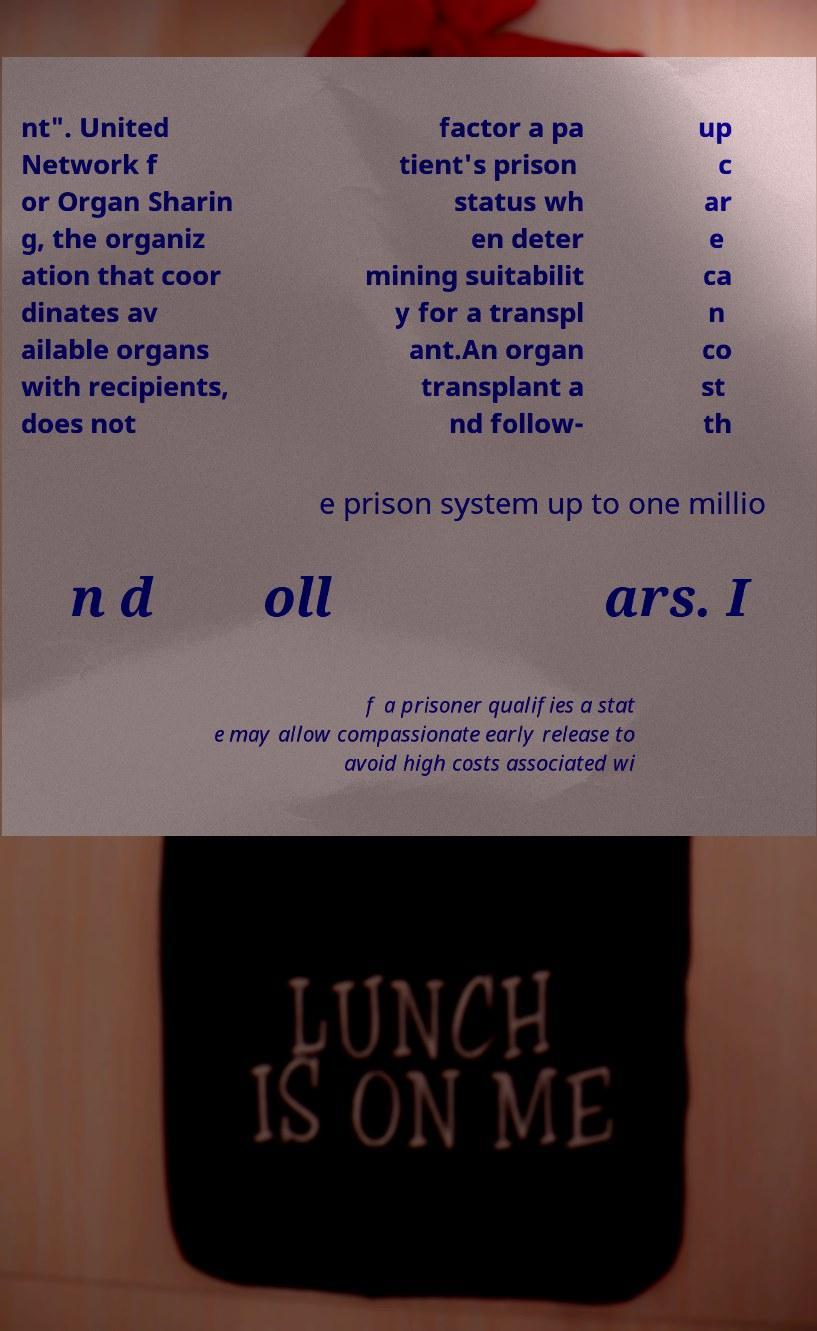Can you read and provide the text displayed in the image?This photo seems to have some interesting text. Can you extract and type it out for me? nt". United Network f or Organ Sharin g, the organiz ation that coor dinates av ailable organs with recipients, does not factor a pa tient's prison status wh en deter mining suitabilit y for a transpl ant.An organ transplant a nd follow- up c ar e ca n co st th e prison system up to one millio n d oll ars. I f a prisoner qualifies a stat e may allow compassionate early release to avoid high costs associated wi 